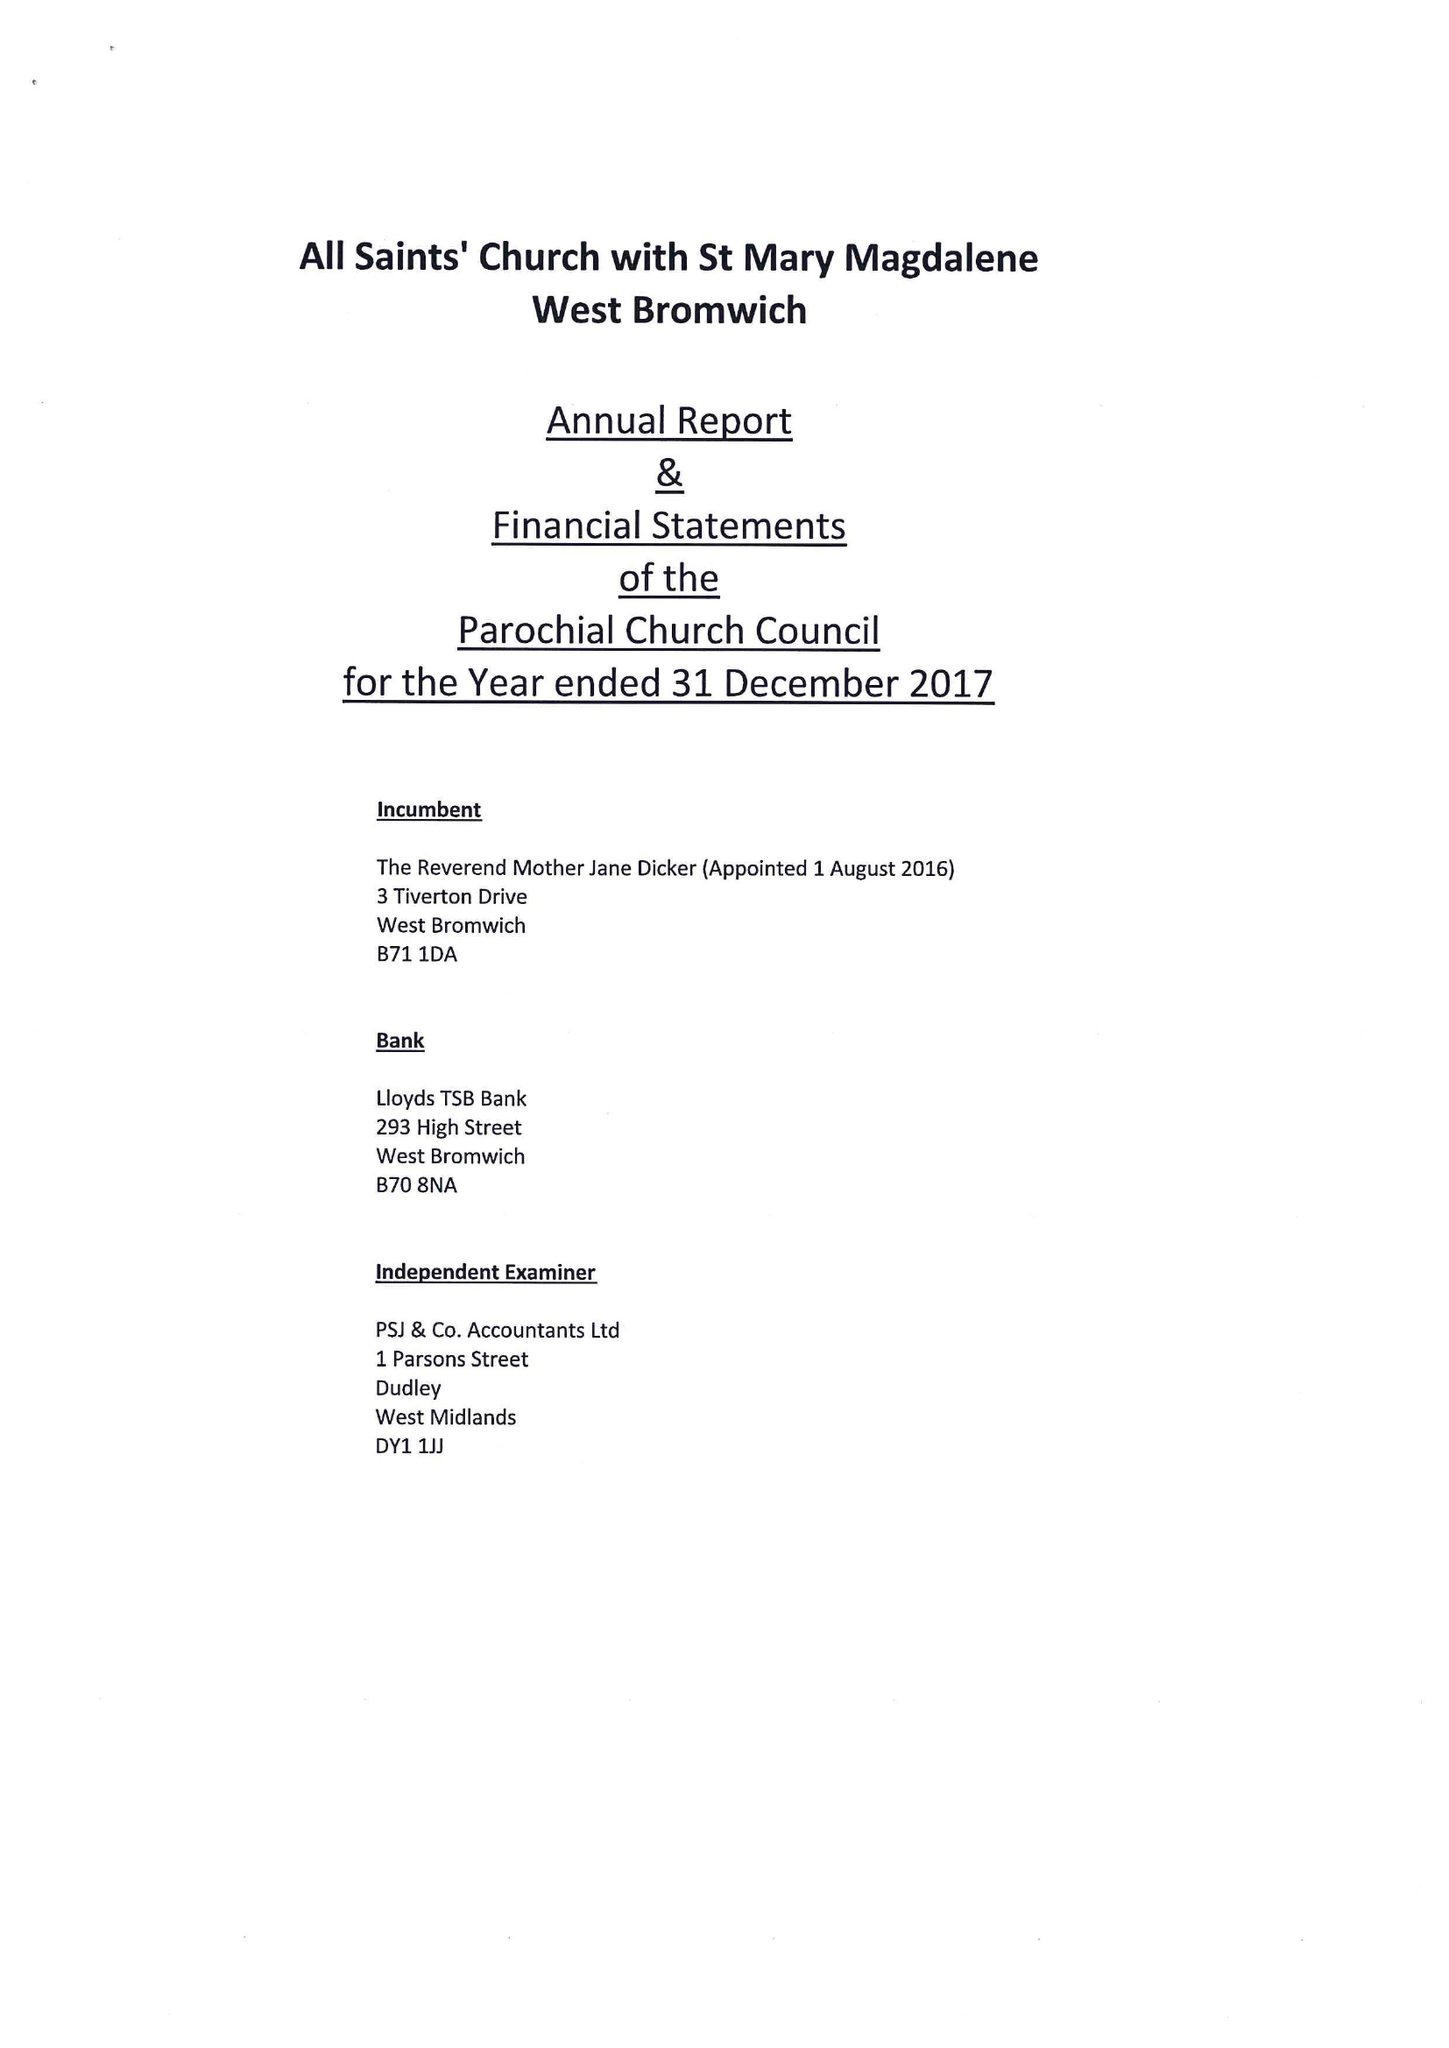What is the value for the income_annually_in_british_pounds?
Answer the question using a single word or phrase. 162069.00 